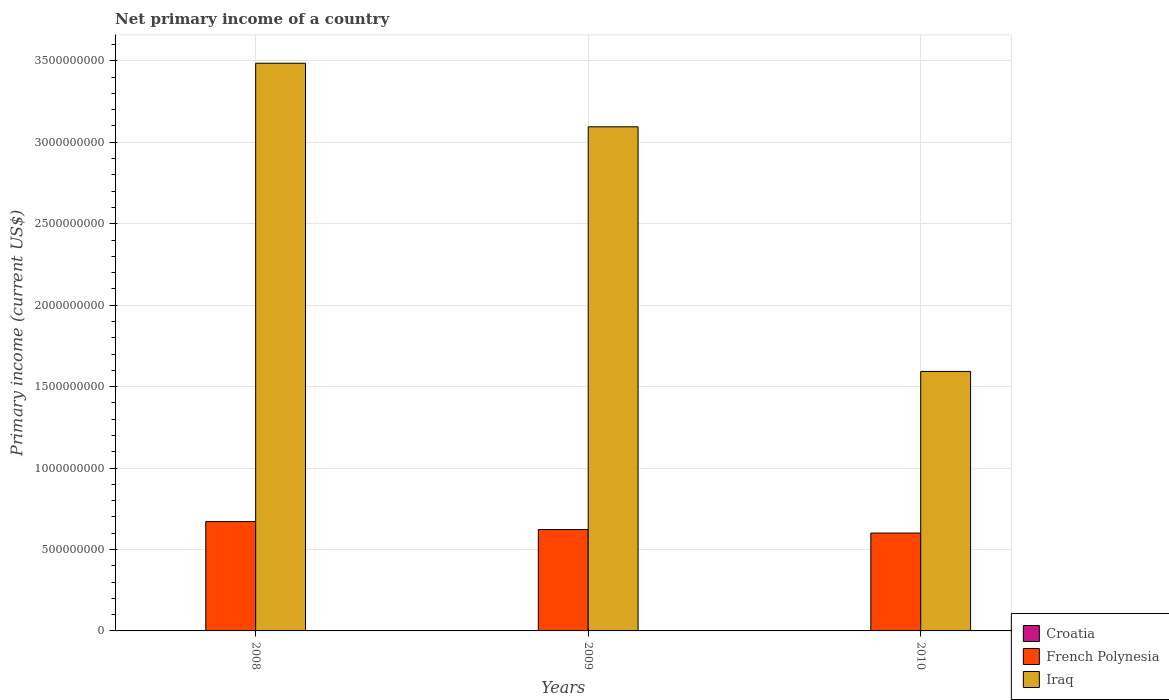How many different coloured bars are there?
Offer a terse response. 2. Are the number of bars on each tick of the X-axis equal?
Provide a succinct answer. Yes. What is the primary income in Iraq in 2008?
Make the answer very short. 3.49e+09. Across all years, what is the maximum primary income in French Polynesia?
Ensure brevity in your answer.  6.71e+08. In which year was the primary income in Iraq maximum?
Make the answer very short. 2008. What is the total primary income in Croatia in the graph?
Give a very brief answer. 0. What is the difference between the primary income in French Polynesia in 2008 and that in 2010?
Keep it short and to the point. 7.04e+07. What is the difference between the primary income in French Polynesia in 2008 and the primary income in Iraq in 2010?
Your answer should be compact. -9.22e+08. What is the average primary income in Iraq per year?
Give a very brief answer. 2.72e+09. In the year 2008, what is the difference between the primary income in French Polynesia and primary income in Iraq?
Give a very brief answer. -2.81e+09. What is the ratio of the primary income in French Polynesia in 2009 to that in 2010?
Offer a terse response. 1.04. What is the difference between the highest and the second highest primary income in Iraq?
Give a very brief answer. 3.90e+08. What is the difference between the highest and the lowest primary income in Iraq?
Make the answer very short. 1.89e+09. Is the sum of the primary income in Iraq in 2008 and 2010 greater than the maximum primary income in Croatia across all years?
Ensure brevity in your answer.  Yes. How many bars are there?
Offer a terse response. 6. Are all the bars in the graph horizontal?
Provide a succinct answer. No. How many years are there in the graph?
Your response must be concise. 3. Does the graph contain any zero values?
Your answer should be compact. Yes. How many legend labels are there?
Make the answer very short. 3. How are the legend labels stacked?
Offer a very short reply. Vertical. What is the title of the graph?
Offer a very short reply. Net primary income of a country. What is the label or title of the X-axis?
Provide a succinct answer. Years. What is the label or title of the Y-axis?
Make the answer very short. Primary income (current US$). What is the Primary income (current US$) of French Polynesia in 2008?
Offer a very short reply. 6.71e+08. What is the Primary income (current US$) of Iraq in 2008?
Provide a succinct answer. 3.49e+09. What is the Primary income (current US$) of Croatia in 2009?
Keep it short and to the point. 0. What is the Primary income (current US$) in French Polynesia in 2009?
Ensure brevity in your answer.  6.22e+08. What is the Primary income (current US$) of Iraq in 2009?
Your response must be concise. 3.10e+09. What is the Primary income (current US$) of Croatia in 2010?
Keep it short and to the point. 0. What is the Primary income (current US$) in French Polynesia in 2010?
Your answer should be very brief. 6.01e+08. What is the Primary income (current US$) in Iraq in 2010?
Ensure brevity in your answer.  1.59e+09. Across all years, what is the maximum Primary income (current US$) of French Polynesia?
Offer a very short reply. 6.71e+08. Across all years, what is the maximum Primary income (current US$) in Iraq?
Your answer should be compact. 3.49e+09. Across all years, what is the minimum Primary income (current US$) in French Polynesia?
Keep it short and to the point. 6.01e+08. Across all years, what is the minimum Primary income (current US$) in Iraq?
Offer a terse response. 1.59e+09. What is the total Primary income (current US$) of French Polynesia in the graph?
Your response must be concise. 1.89e+09. What is the total Primary income (current US$) in Iraq in the graph?
Provide a short and direct response. 8.17e+09. What is the difference between the Primary income (current US$) in French Polynesia in 2008 and that in 2009?
Your answer should be compact. 4.90e+07. What is the difference between the Primary income (current US$) in Iraq in 2008 and that in 2009?
Make the answer very short. 3.90e+08. What is the difference between the Primary income (current US$) of French Polynesia in 2008 and that in 2010?
Give a very brief answer. 7.04e+07. What is the difference between the Primary income (current US$) in Iraq in 2008 and that in 2010?
Give a very brief answer. 1.89e+09. What is the difference between the Primary income (current US$) in French Polynesia in 2009 and that in 2010?
Make the answer very short. 2.14e+07. What is the difference between the Primary income (current US$) in Iraq in 2009 and that in 2010?
Provide a short and direct response. 1.50e+09. What is the difference between the Primary income (current US$) of French Polynesia in 2008 and the Primary income (current US$) of Iraq in 2009?
Keep it short and to the point. -2.42e+09. What is the difference between the Primary income (current US$) in French Polynesia in 2008 and the Primary income (current US$) in Iraq in 2010?
Provide a short and direct response. -9.22e+08. What is the difference between the Primary income (current US$) of French Polynesia in 2009 and the Primary income (current US$) of Iraq in 2010?
Your response must be concise. -9.71e+08. What is the average Primary income (current US$) in Croatia per year?
Ensure brevity in your answer.  0. What is the average Primary income (current US$) of French Polynesia per year?
Offer a very short reply. 6.31e+08. What is the average Primary income (current US$) of Iraq per year?
Provide a succinct answer. 2.72e+09. In the year 2008, what is the difference between the Primary income (current US$) of French Polynesia and Primary income (current US$) of Iraq?
Your answer should be very brief. -2.81e+09. In the year 2009, what is the difference between the Primary income (current US$) in French Polynesia and Primary income (current US$) in Iraq?
Provide a short and direct response. -2.47e+09. In the year 2010, what is the difference between the Primary income (current US$) in French Polynesia and Primary income (current US$) in Iraq?
Give a very brief answer. -9.92e+08. What is the ratio of the Primary income (current US$) in French Polynesia in 2008 to that in 2009?
Provide a short and direct response. 1.08. What is the ratio of the Primary income (current US$) of Iraq in 2008 to that in 2009?
Give a very brief answer. 1.13. What is the ratio of the Primary income (current US$) in French Polynesia in 2008 to that in 2010?
Give a very brief answer. 1.12. What is the ratio of the Primary income (current US$) of Iraq in 2008 to that in 2010?
Offer a terse response. 2.19. What is the ratio of the Primary income (current US$) in French Polynesia in 2009 to that in 2010?
Ensure brevity in your answer.  1.04. What is the ratio of the Primary income (current US$) of Iraq in 2009 to that in 2010?
Your answer should be very brief. 1.94. What is the difference between the highest and the second highest Primary income (current US$) of French Polynesia?
Your response must be concise. 4.90e+07. What is the difference between the highest and the second highest Primary income (current US$) of Iraq?
Keep it short and to the point. 3.90e+08. What is the difference between the highest and the lowest Primary income (current US$) of French Polynesia?
Provide a short and direct response. 7.04e+07. What is the difference between the highest and the lowest Primary income (current US$) in Iraq?
Provide a succinct answer. 1.89e+09. 